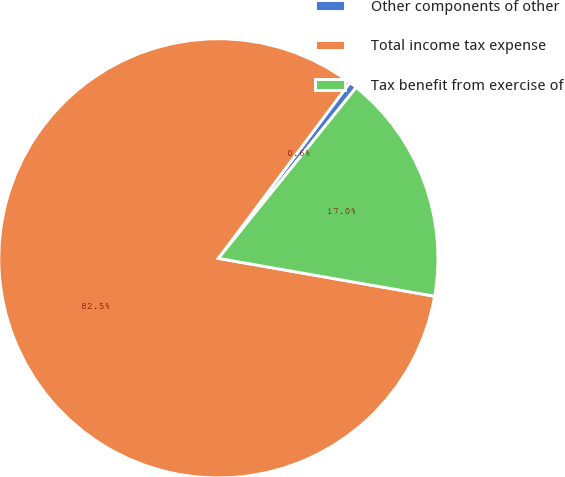Convert chart. <chart><loc_0><loc_0><loc_500><loc_500><pie_chart><fcel>Other components of other<fcel>Total income tax expense<fcel>Tax benefit from exercise of<nl><fcel>0.58%<fcel>82.47%<fcel>16.96%<nl></chart> 